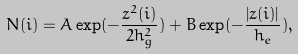<formula> <loc_0><loc_0><loc_500><loc_500>N ( i ) = A \exp ( - \frac { z ^ { 2 } ( i ) } { 2 h _ { g } ^ { 2 } } ) + B \exp ( - \frac { \left | z ( i ) \right | } { h _ { e } } ) ,</formula> 